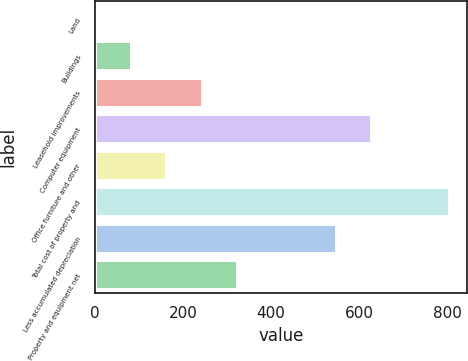Convert chart. <chart><loc_0><loc_0><loc_500><loc_500><bar_chart><fcel>Land<fcel>Buildings<fcel>Leasehold improvements<fcel>Computer equipment<fcel>Office furniture and other<fcel>Total cost of property and<fcel>Less accumulated depreciation<fcel>Property and equipment net<nl><fcel>1<fcel>81.4<fcel>242.2<fcel>627.4<fcel>161.8<fcel>805<fcel>547<fcel>322.6<nl></chart> 